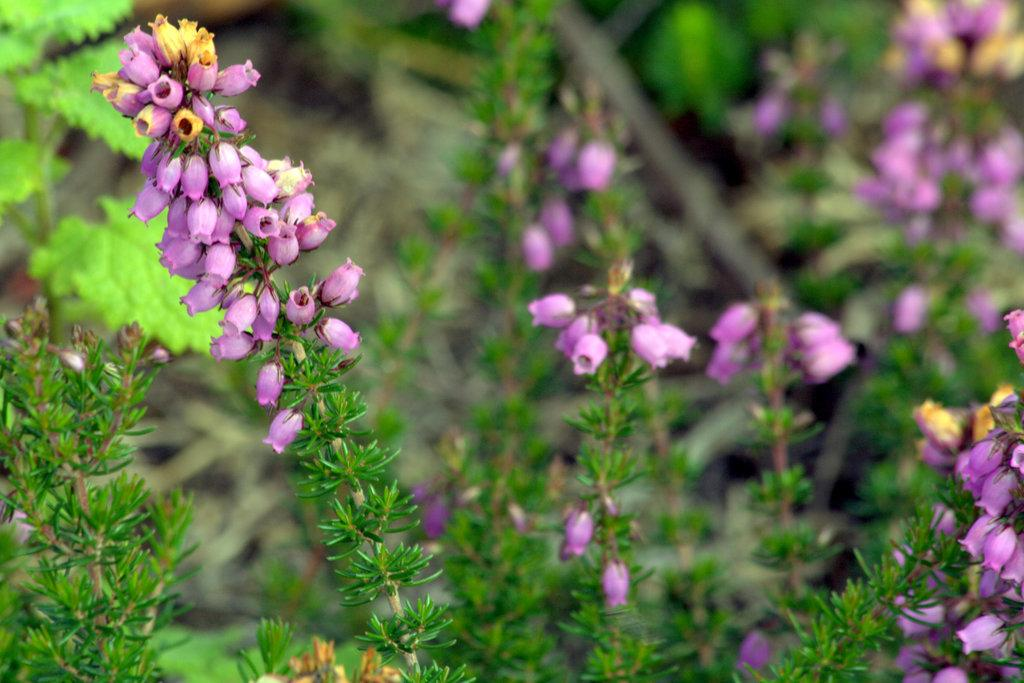What is in the foreground of the image? There are plants and flowers in the foreground of the image. What can be seen in the background of the image? There are leaves and plants in the background of the image. How is the background of the image depicted? The background of the image is blurred. What type of list can be seen hanging on the plants in the image? There is no list present in the image; it features plants and flowers in the foreground and leaves and plants in the background. Can you tell me how many horns are visible in the image? There are no horns visible in the image. 